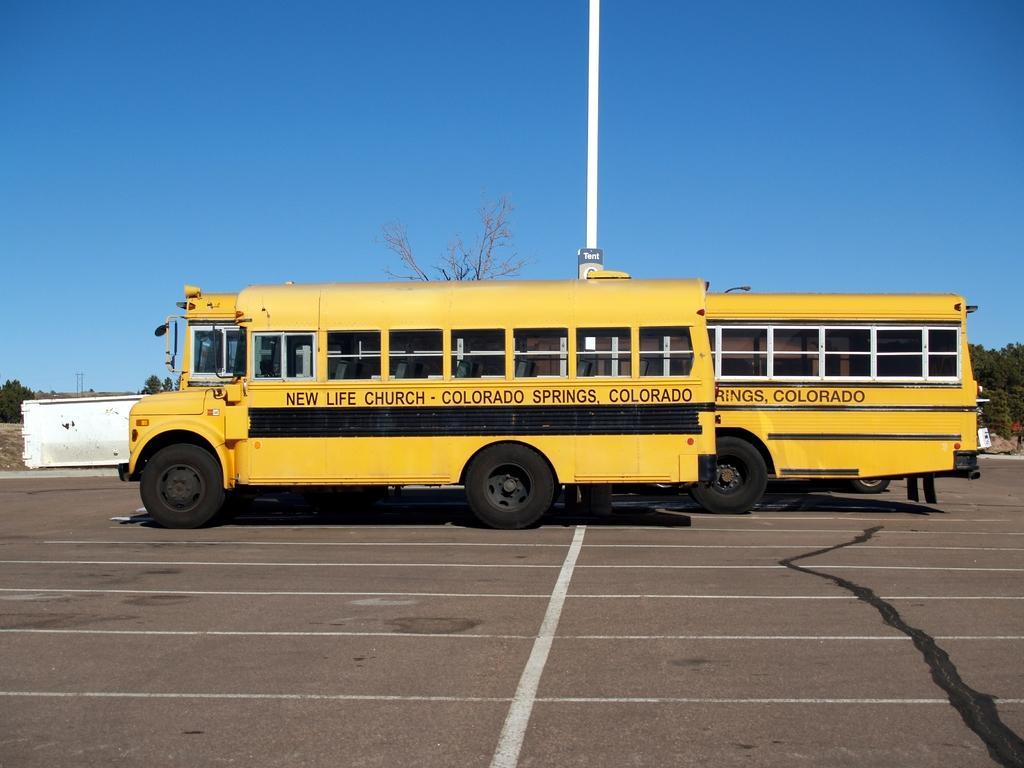Can you describe this image briefly? This picture might be taken on the wide road. In this image, in the middle, we can see two buses which are moving on the road. On the right side, we can see the legs of the person and few vehicles, trees, plants. On the left side, we can also see a white wall color, trees, plants. In the background, we can see the white color pole, trees. At the top, we can see a sky which is in blue color, at the bottom, we can see a road and a shadow in the right corner. 